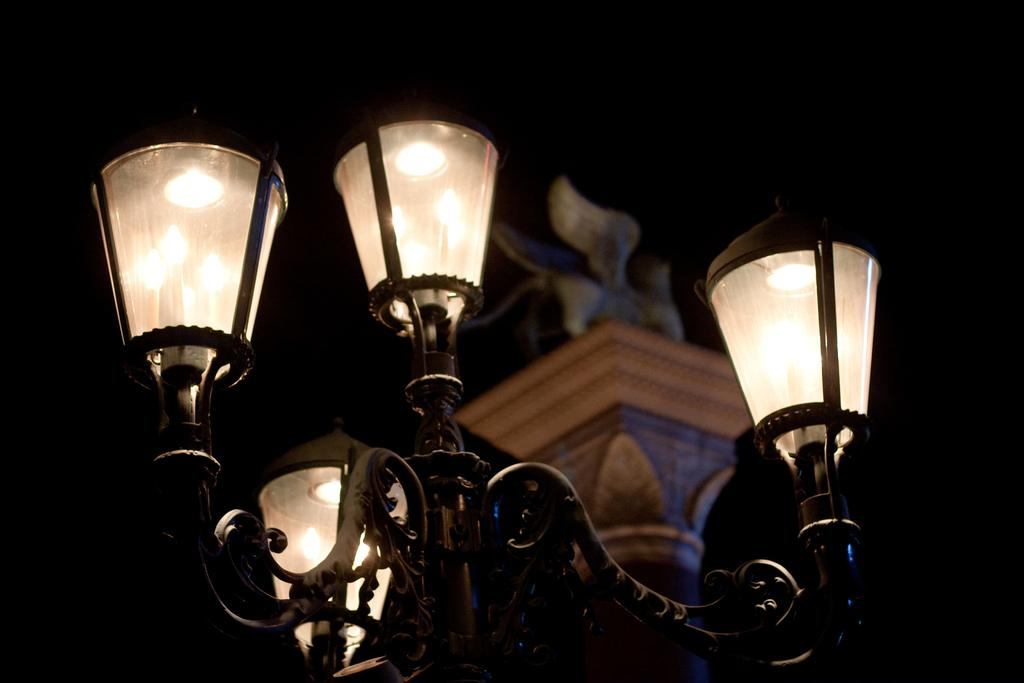What can be seen in the image that provides illumination? There are lights in the image. What else is present in the image besides the lights? There are objects in the image. How would you describe the overall appearance of the image? The background of the image is dark. What type of oatmeal is being served in the image? There is no oatmeal present in the image. What time is displayed on the clock in the image? There is no clock present in the image. 